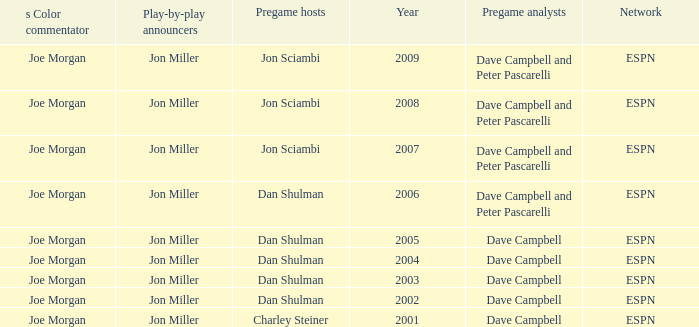Who is the pregame host when the pregame analysts is  Dave Campbell and the year is 2001? Charley Steiner. 